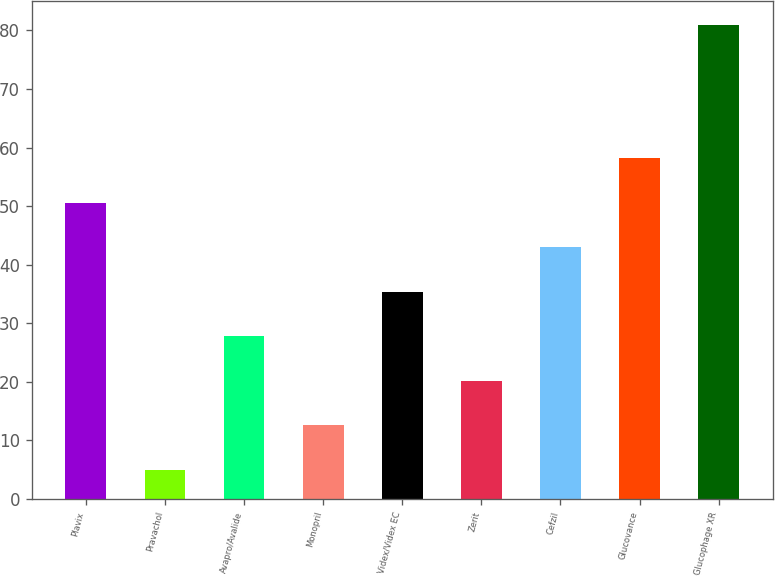Convert chart to OTSL. <chart><loc_0><loc_0><loc_500><loc_500><bar_chart><fcel>Plavix<fcel>Pravachol<fcel>Avapro/Avalide<fcel>Monopril<fcel>Videx/Videx EC<fcel>Zerit<fcel>Cefzil<fcel>Glucovance<fcel>Glucophage XR<nl><fcel>50.6<fcel>5<fcel>27.8<fcel>12.6<fcel>35.4<fcel>20.2<fcel>43<fcel>58.2<fcel>81<nl></chart> 